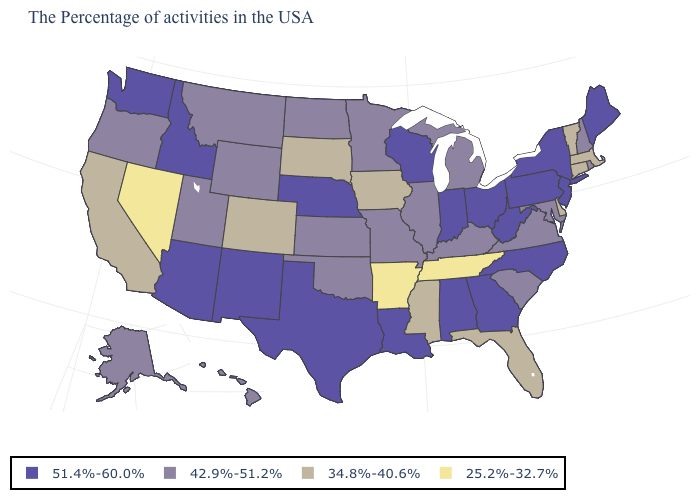Name the states that have a value in the range 25.2%-32.7%?
Write a very short answer. Tennessee, Arkansas, Nevada. What is the value of Oklahoma?
Answer briefly. 42.9%-51.2%. What is the value of Nebraska?
Write a very short answer. 51.4%-60.0%. How many symbols are there in the legend?
Answer briefly. 4. Name the states that have a value in the range 51.4%-60.0%?
Short answer required. Maine, New York, New Jersey, Pennsylvania, North Carolina, West Virginia, Ohio, Georgia, Indiana, Alabama, Wisconsin, Louisiana, Nebraska, Texas, New Mexico, Arizona, Idaho, Washington. Name the states that have a value in the range 25.2%-32.7%?
Answer briefly. Tennessee, Arkansas, Nevada. Name the states that have a value in the range 42.9%-51.2%?
Quick response, please. Rhode Island, New Hampshire, Maryland, Virginia, South Carolina, Michigan, Kentucky, Illinois, Missouri, Minnesota, Kansas, Oklahoma, North Dakota, Wyoming, Utah, Montana, Oregon, Alaska, Hawaii. Does Wisconsin have the same value as Maine?
Quick response, please. Yes. Does the first symbol in the legend represent the smallest category?
Quick response, please. No. What is the highest value in the West ?
Keep it brief. 51.4%-60.0%. What is the value of Wyoming?
Give a very brief answer. 42.9%-51.2%. What is the highest value in states that border Nevada?
Answer briefly. 51.4%-60.0%. Which states hav the highest value in the South?
Be succinct. North Carolina, West Virginia, Georgia, Alabama, Louisiana, Texas. Name the states that have a value in the range 34.8%-40.6%?
Concise answer only. Massachusetts, Vermont, Connecticut, Delaware, Florida, Mississippi, Iowa, South Dakota, Colorado, California. What is the value of Massachusetts?
Be succinct. 34.8%-40.6%. 